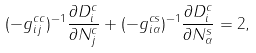Convert formula to latex. <formula><loc_0><loc_0><loc_500><loc_500>( - g _ { i j } ^ { c c } ) ^ { - 1 } \frac { \partial D _ { i } ^ { c } } { \partial N _ { j } ^ { c } } + ( - g _ { i \alpha } ^ { c s } ) ^ { - 1 } \frac { \partial D _ { i } ^ { c } } { \partial N _ { \alpha } ^ { s } } = 2 ,</formula> 